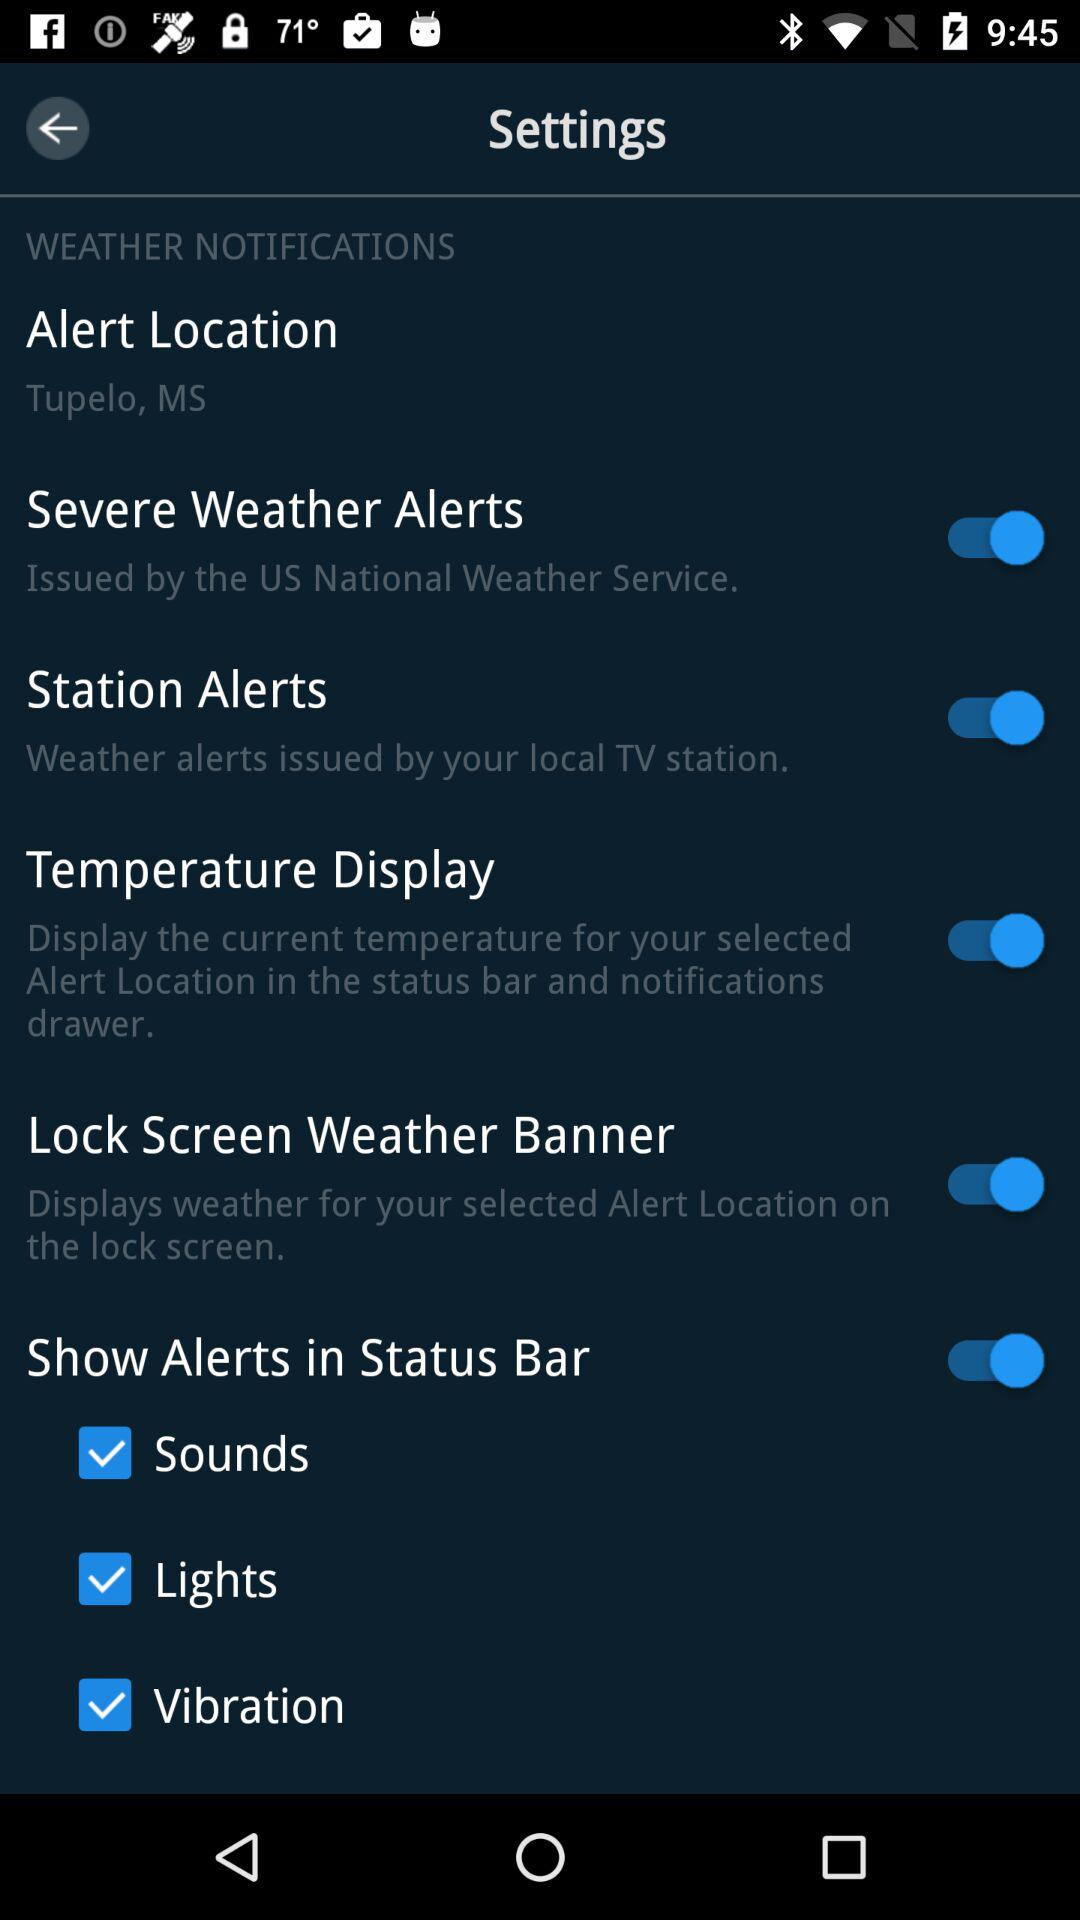How many types of alerts are available?
Answer the question using a single word or phrase. 3 